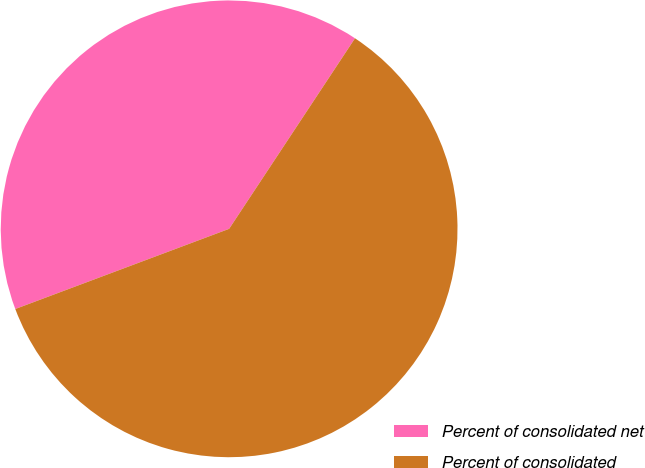Convert chart. <chart><loc_0><loc_0><loc_500><loc_500><pie_chart><fcel>Percent of consolidated net<fcel>Percent of consolidated<nl><fcel>40.0%<fcel>60.0%<nl></chart> 